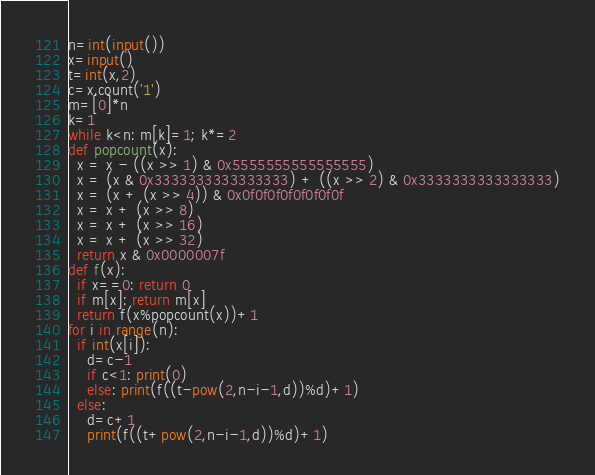Convert code to text. <code><loc_0><loc_0><loc_500><loc_500><_Python_>n=int(input())
x=input()
t=int(x,2)
c=x.count('1')
m=[0]*n
k=1
while k<n: m[k]=1; k*=2
def popcount(x):
  x = x - ((x >> 1) & 0x5555555555555555)
  x = (x & 0x3333333333333333) + ((x >> 2) & 0x3333333333333333)
  x = (x + (x >> 4)) & 0x0f0f0f0f0f0f0f0f
  x = x + (x >> 8)
  x = x + (x >> 16)
  x = x + (x >> 32)
  return x & 0x0000007f
def f(x):
  if x==0: return 0
  if m[x]: return m[x]
  return f(x%popcount(x))+1
for i in range(n):
  if int(x[i]):
    d=c-1
    if c<1: print(0)
    else: print(f((t-pow(2,n-i-1,d))%d)+1)
  else:
    d=c+1
    print(f((t+pow(2,n-i-1,d))%d)+1)</code> 